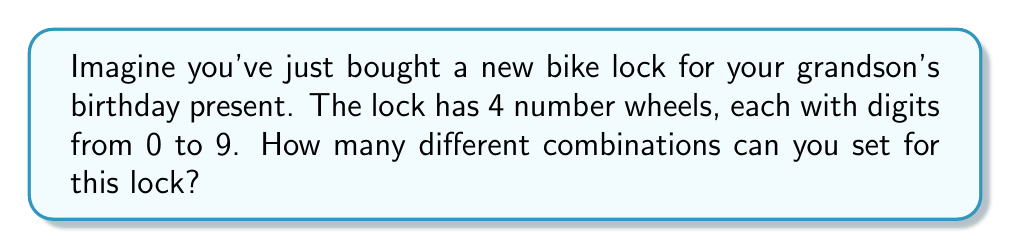Teach me how to tackle this problem. Let's approach this step-by-step:

1. First, we need to understand what the question is asking. We're looking for the total number of possible combinations for a lock with 4 wheels, each containing digits 0-9.

2. This is a perfect example of the multiplication principle in combinatorics. When we have independent choices, we multiply the number of options for each choice.

3. For each wheel:
   - We have 10 choices (digits 0-9)
   - This is true for all 4 wheels

4. Therefore, we can calculate the total number of combinations as:

   $$ 10 \times 10 \times 10 \times 10 $$

5. This can be written more concisely as:

   $$ 10^4 $$

6. Calculating this:
   $$ 10^4 = 10,000 $$

So, there are 10,000 possible combinations for this lock.
Answer: 10,000 